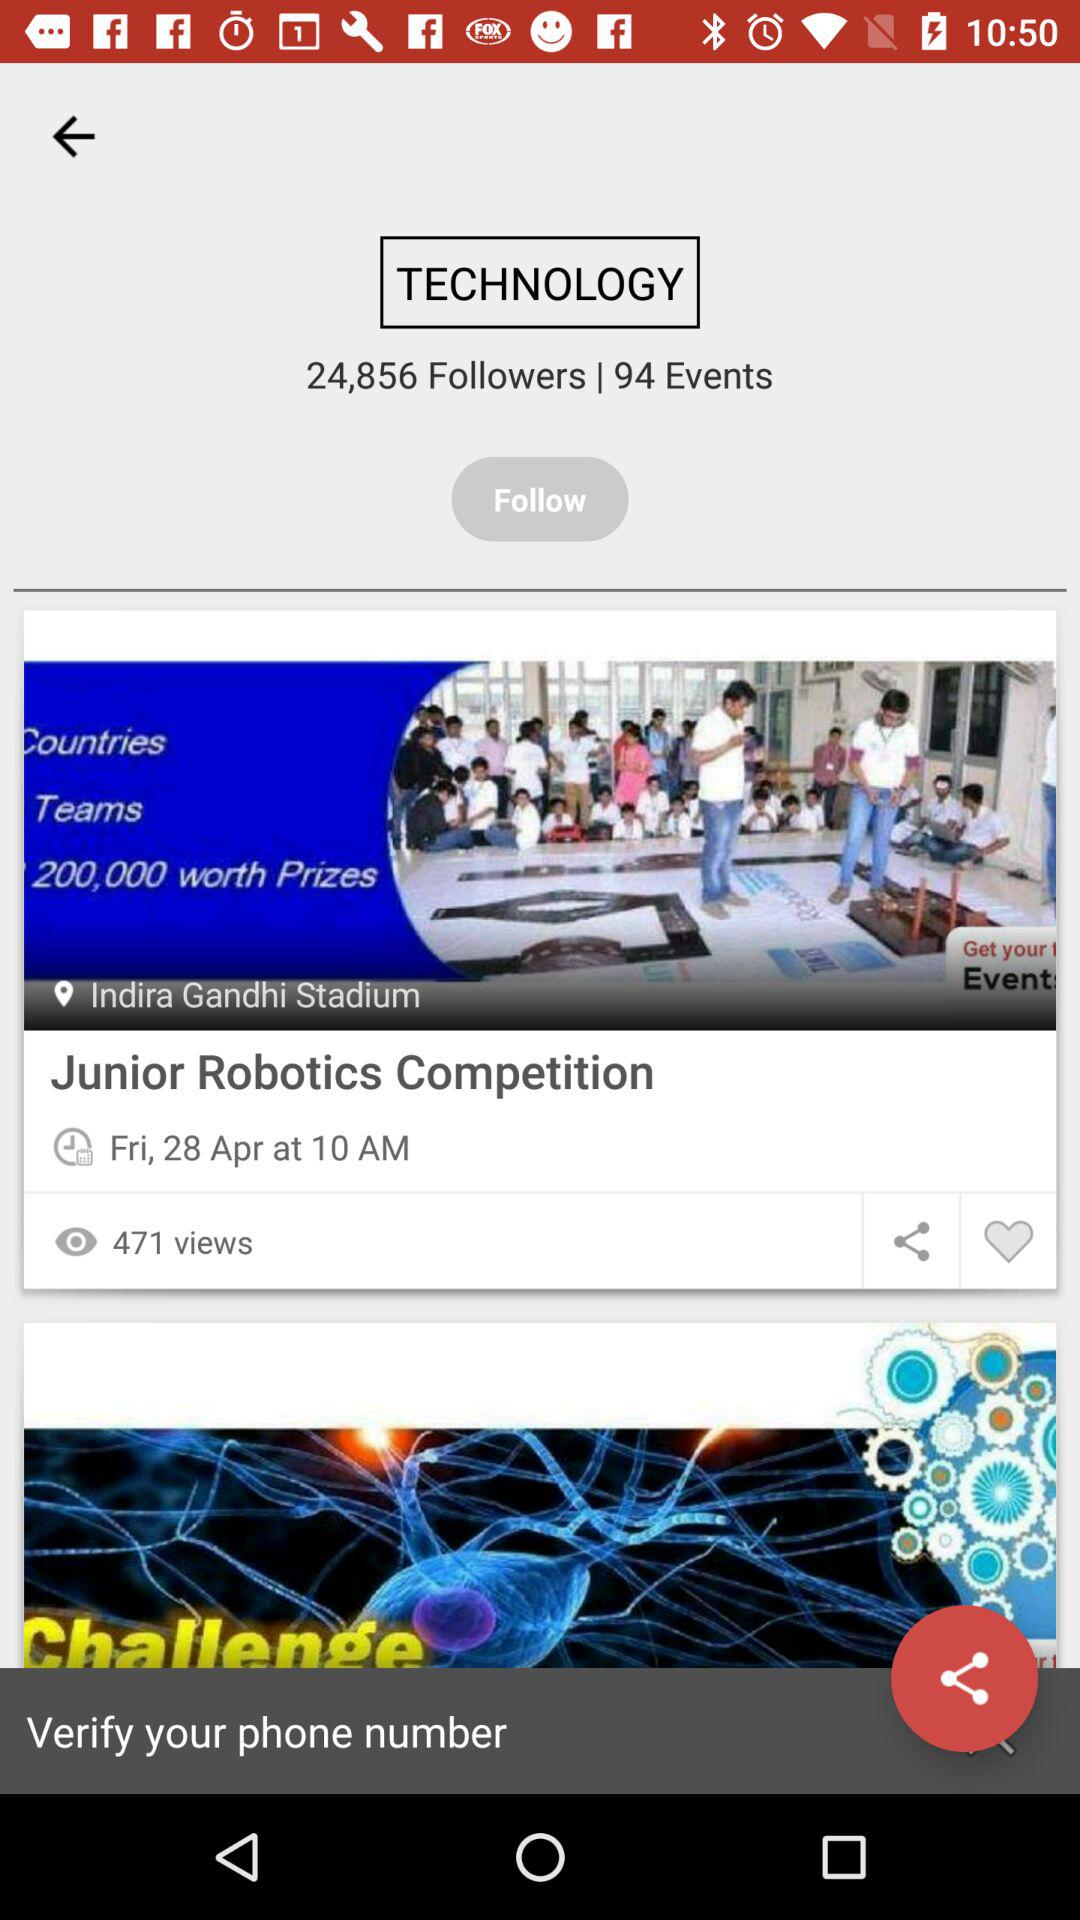What is the location of the "Junior Robotics Competition"? The location is Indira Gandhi Stadium. 